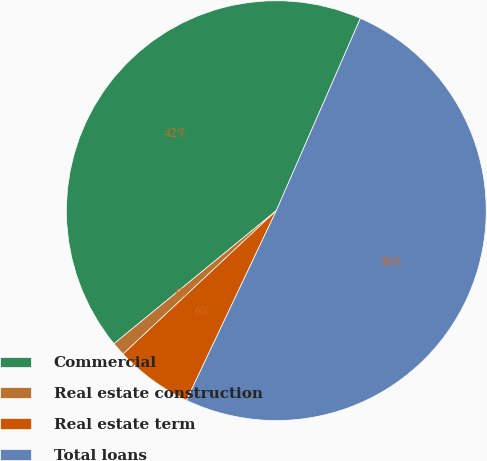<chart> <loc_0><loc_0><loc_500><loc_500><pie_chart><fcel>Commercial<fcel>Real estate construction<fcel>Real estate term<fcel>Total loans<nl><fcel>42.49%<fcel>1.04%<fcel>5.99%<fcel>50.47%<nl></chart> 